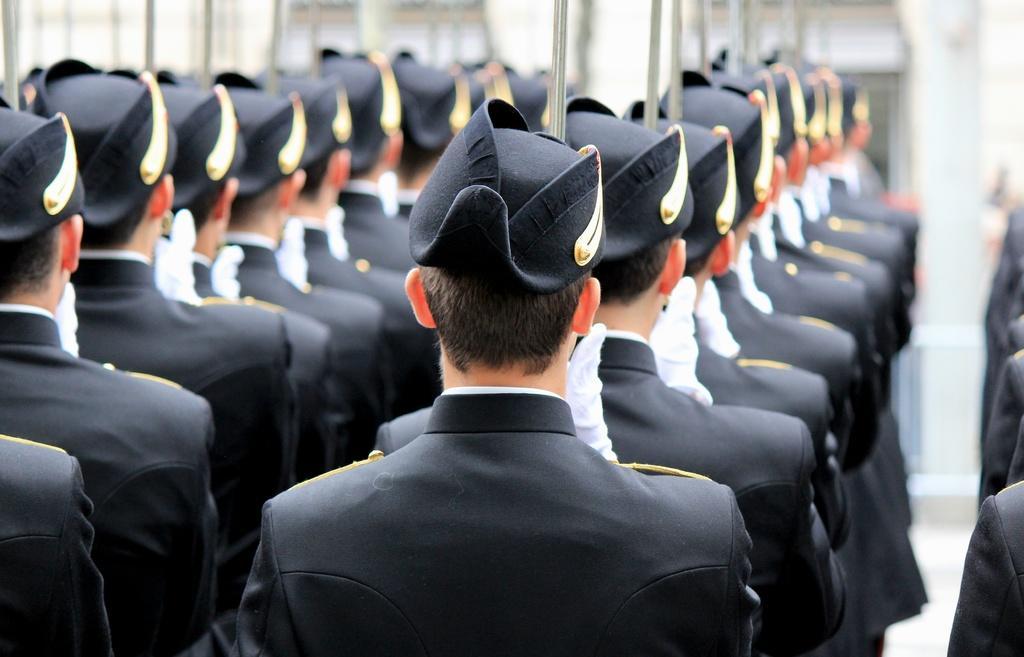Describe this image in one or two sentences. There are people those who are standing in series in the same uniform in the image, it seems to like there is a pillar and windows in the background area. 